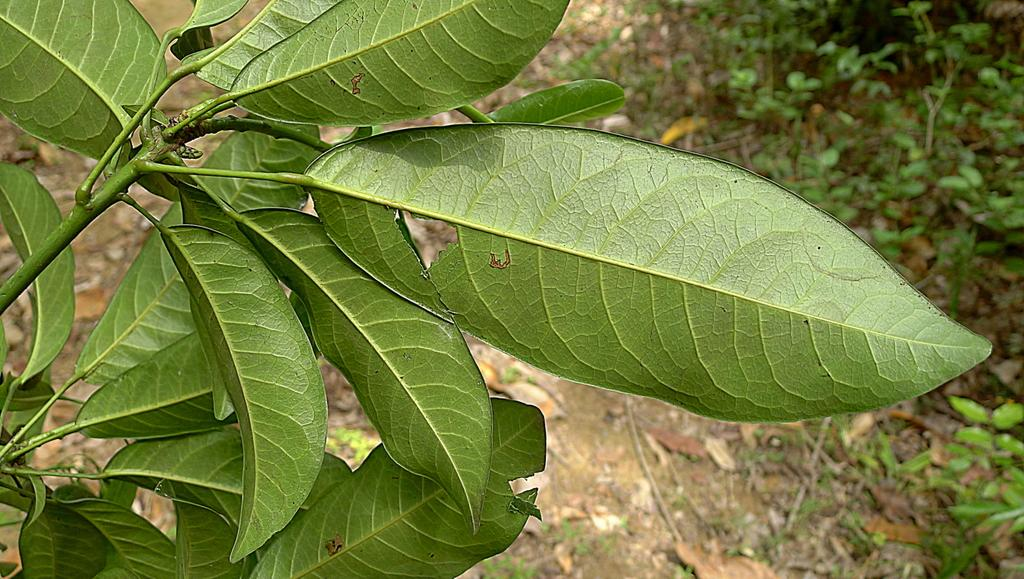What type of vegetation can be seen in the image? There are leaves visible in the image. Where are the plants located in the image? The plants are on the right side of the image. What type of soap is being used to clean the ball in the image? There is no soap or ball present in the image; it only features leaves and plants. 